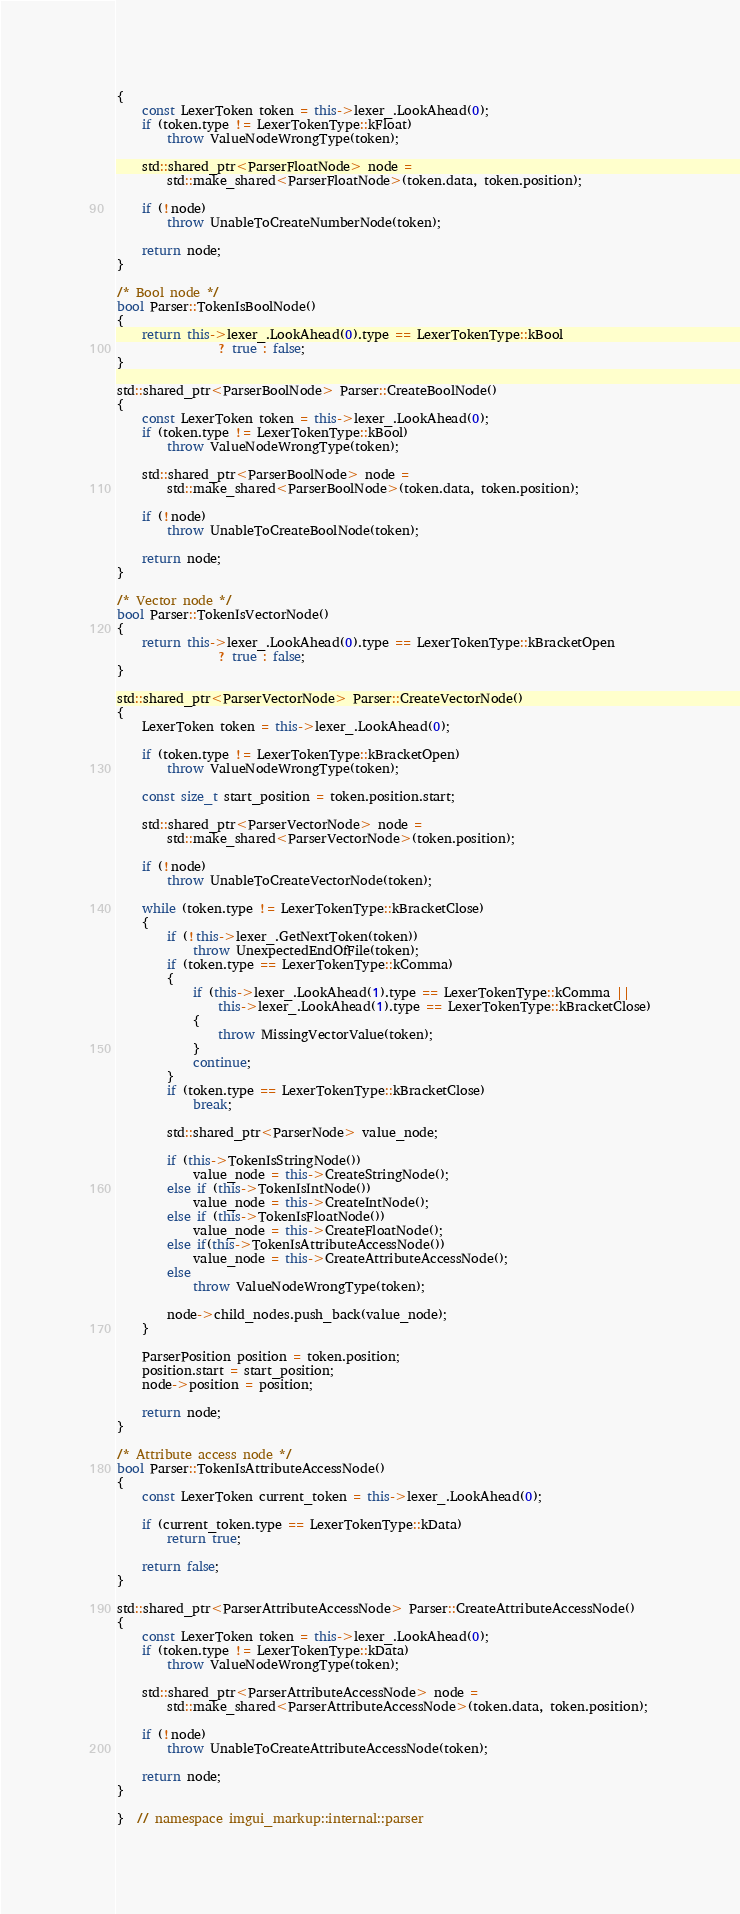Convert code to text. <code><loc_0><loc_0><loc_500><loc_500><_C++_>{
    const LexerToken token = this->lexer_.LookAhead(0);
    if (token.type != LexerTokenType::kFloat)
        throw ValueNodeWrongType(token);

    std::shared_ptr<ParserFloatNode> node =
        std::make_shared<ParserFloatNode>(token.data, token.position);

    if (!node)
        throw UnableToCreateNumberNode(token);

    return node;
}

/* Bool node */
bool Parser::TokenIsBoolNode()
{
    return this->lexer_.LookAhead(0).type == LexerTokenType::kBool
                ? true : false;
}

std::shared_ptr<ParserBoolNode> Parser::CreateBoolNode()
{
    const LexerToken token = this->lexer_.LookAhead(0);
    if (token.type != LexerTokenType::kBool)
        throw ValueNodeWrongType(token);

    std::shared_ptr<ParserBoolNode> node =
        std::make_shared<ParserBoolNode>(token.data, token.position);

    if (!node)
        throw UnableToCreateBoolNode(token);

    return node;
}

/* Vector node */
bool Parser::TokenIsVectorNode()
{
    return this->lexer_.LookAhead(0).type == LexerTokenType::kBracketOpen
                ? true : false;
}

std::shared_ptr<ParserVectorNode> Parser::CreateVectorNode()
{
    LexerToken token = this->lexer_.LookAhead(0);

    if (token.type != LexerTokenType::kBracketOpen)
        throw ValueNodeWrongType(token);

    const size_t start_position = token.position.start;

    std::shared_ptr<ParserVectorNode> node =
        std::make_shared<ParserVectorNode>(token.position);

    if (!node)
        throw UnableToCreateVectorNode(token);

    while (token.type != LexerTokenType::kBracketClose)
    {
        if (!this->lexer_.GetNextToken(token))
            throw UnexpectedEndOfFile(token);
        if (token.type == LexerTokenType::kComma)
        {
            if (this->lexer_.LookAhead(1).type == LexerTokenType::kComma ||
                this->lexer_.LookAhead(1).type == LexerTokenType::kBracketClose)
            {
                throw MissingVectorValue(token);
            }
            continue;
        }
        if (token.type == LexerTokenType::kBracketClose)
            break;

        std::shared_ptr<ParserNode> value_node;

        if (this->TokenIsStringNode())
            value_node = this->CreateStringNode();
        else if (this->TokenIsIntNode())
            value_node = this->CreateIntNode();
        else if (this->TokenIsFloatNode())
            value_node = this->CreateFloatNode();
        else if(this->TokenIsAttributeAccessNode())
            value_node = this->CreateAttributeAccessNode();
        else
            throw ValueNodeWrongType(token);

        node->child_nodes.push_back(value_node);
    }

    ParserPosition position = token.position;
    position.start = start_position;
    node->position = position;

    return node;
}

/* Attribute access node */
bool Parser::TokenIsAttributeAccessNode()
{
    const LexerToken current_token = this->lexer_.LookAhead(0);

    if (current_token.type == LexerTokenType::kData)
        return true;

    return false;
}

std::shared_ptr<ParserAttributeAccessNode> Parser::CreateAttributeAccessNode()
{
    const LexerToken token = this->lexer_.LookAhead(0);
    if (token.type != LexerTokenType::kData)
        throw ValueNodeWrongType(token);

    std::shared_ptr<ParserAttributeAccessNode> node =
        std::make_shared<ParserAttributeAccessNode>(token.data, token.position);

    if (!node)
        throw UnableToCreateAttributeAccessNode(token);

    return node;
}

}  // namespace imgui_markup::internal::parser
</code> 